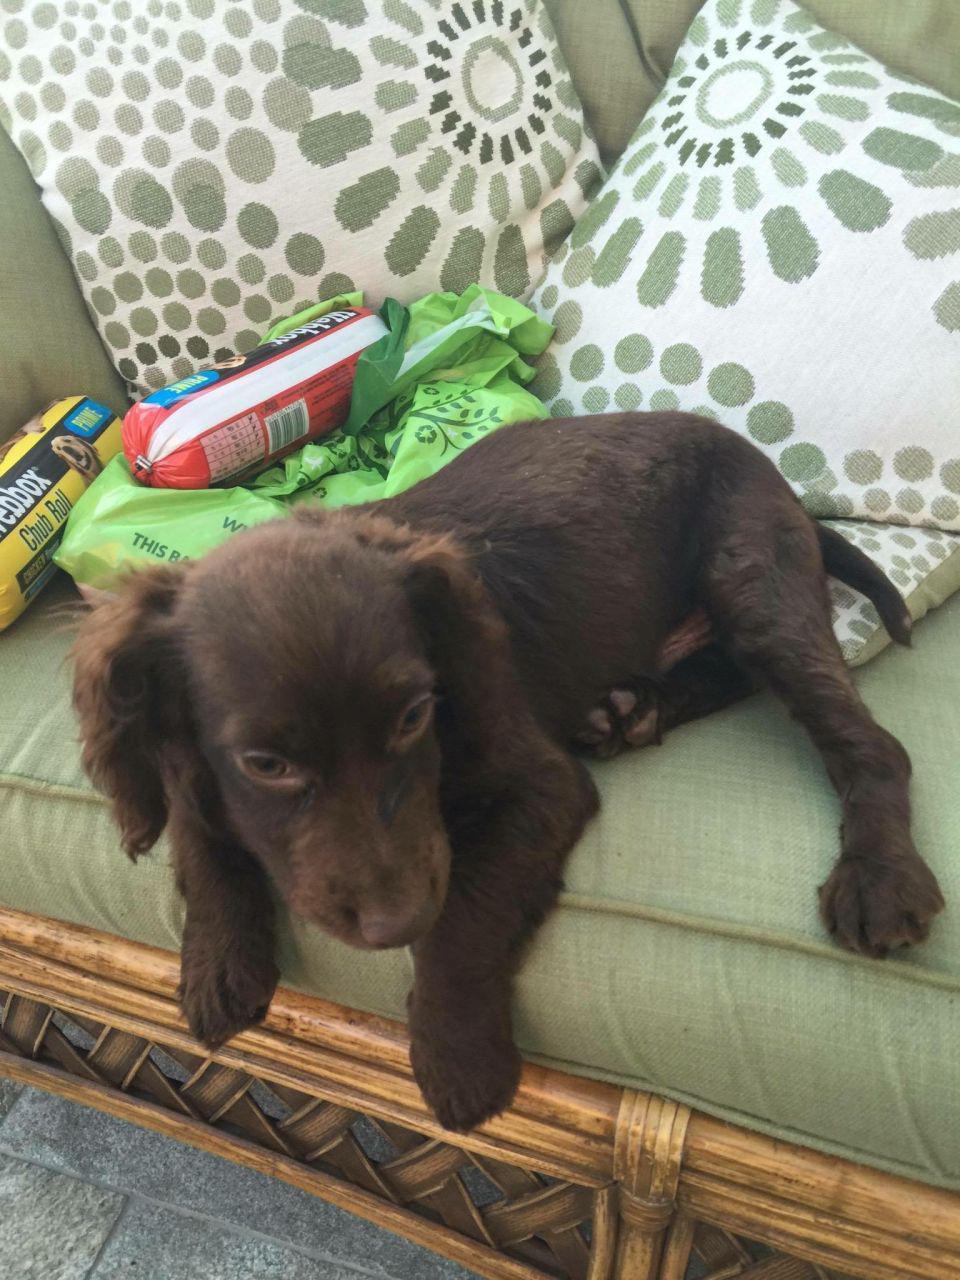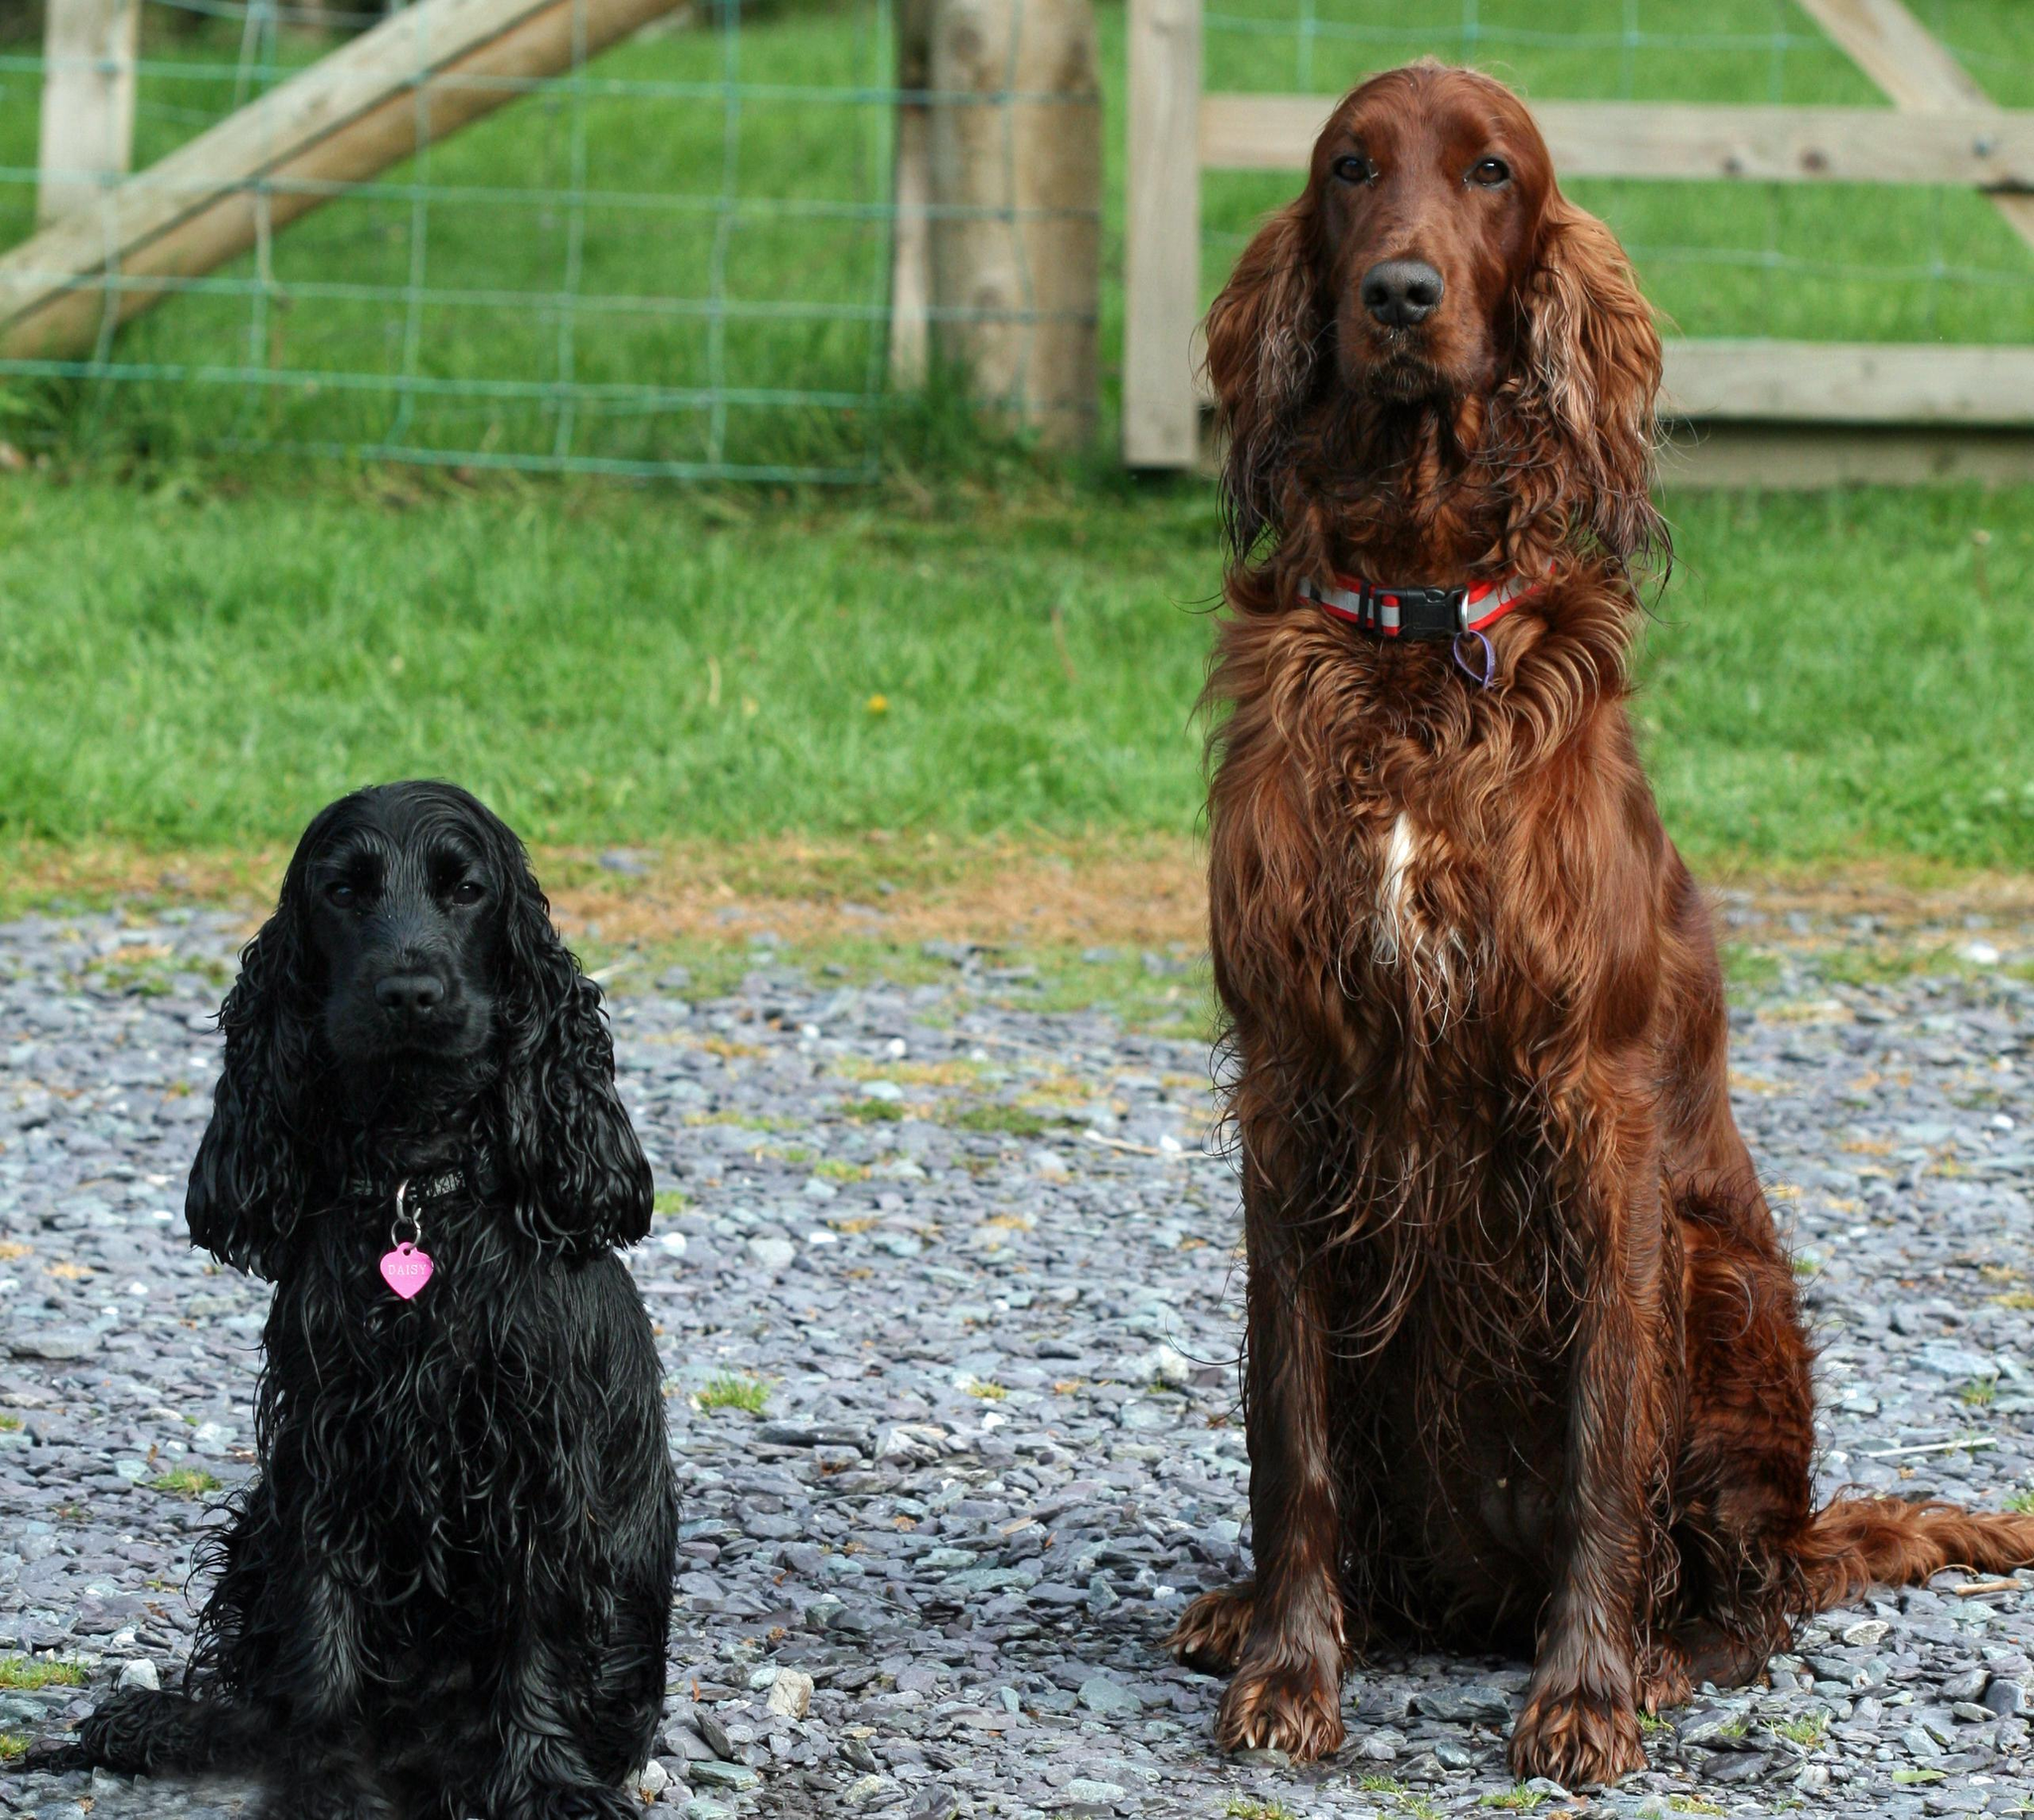The first image is the image on the left, the second image is the image on the right. Analyze the images presented: Is the assertion "A human hand is holding a puppy in the air in one image, and no image contains more than one dog." valid? Answer yes or no. No. The first image is the image on the left, the second image is the image on the right. Examine the images to the left and right. Is the description "A person is holding a dog in at least one of the images." accurate? Answer yes or no. No. 